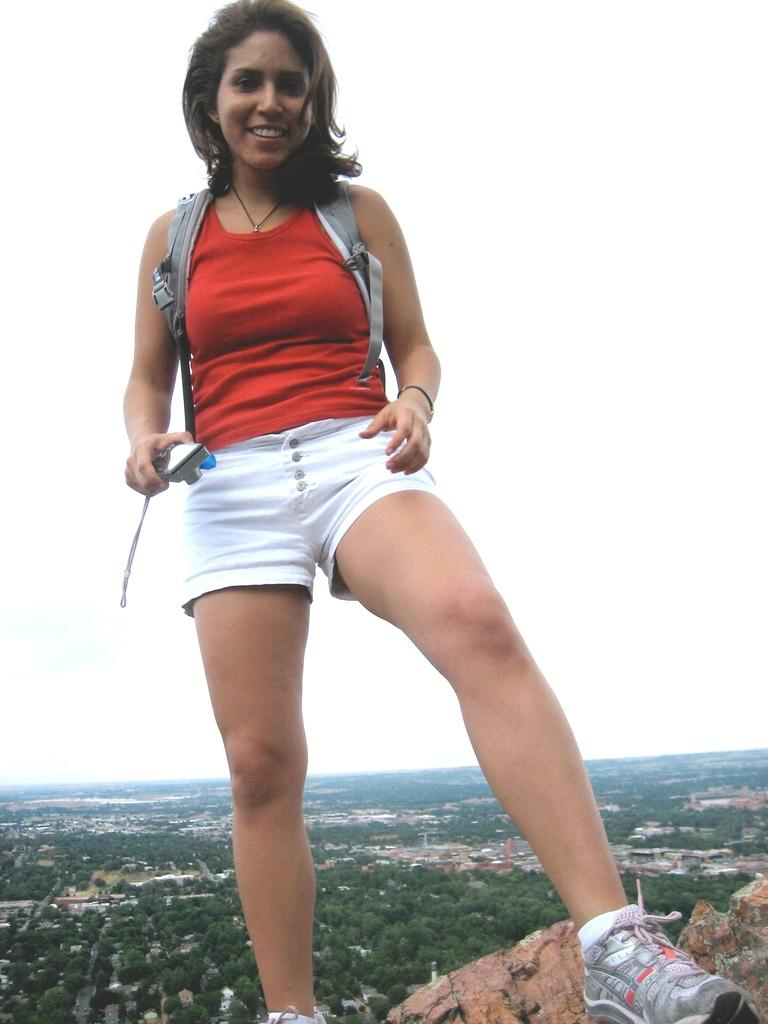Who is the main subject in the image? There is a woman in the image. What is the woman doing in the image? The woman is standing on a rock. What is the woman wearing in the image? The woman is wearing a red top and a shoe. What is the woman holding in the image? The woman is holding a mobile. What can be seen in the background of the image? There are trees, houses, and the sky visible in the background of the image. What type of cloth is being used for the observation in the image? There is no cloth or observation present in the image. What memory is the woman trying to recall in the image? There is no indication of the woman trying to recall a memory in the image. 